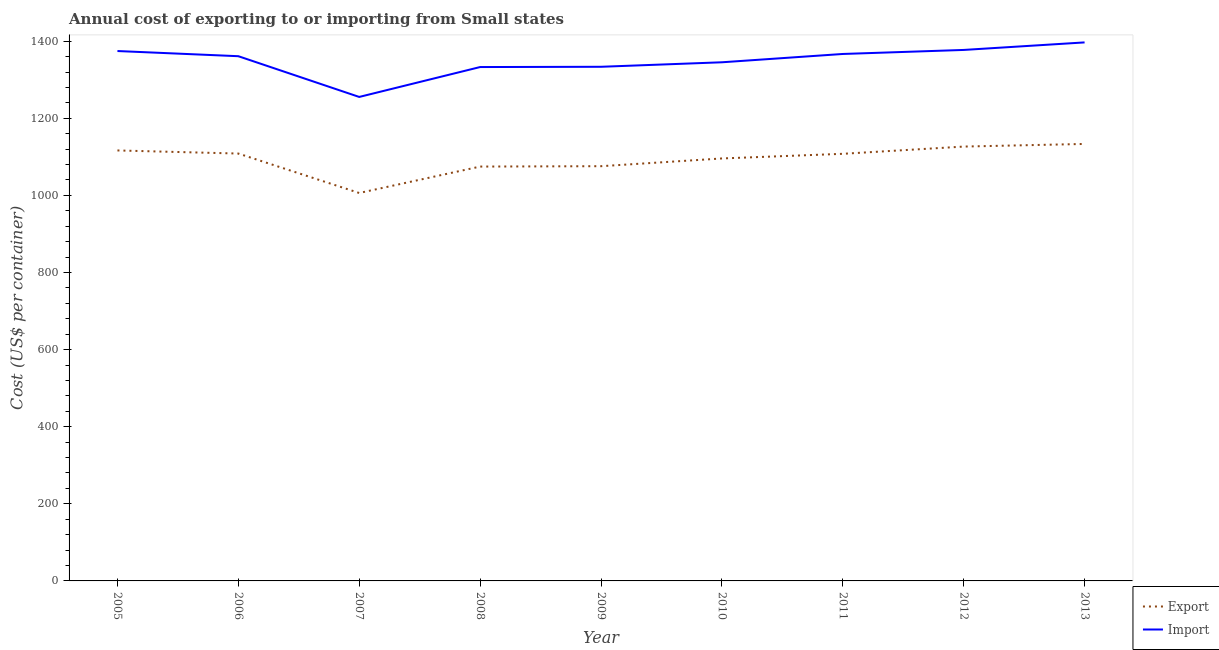How many different coloured lines are there?
Provide a succinct answer. 2. What is the import cost in 2013?
Offer a terse response. 1396.9. Across all years, what is the maximum import cost?
Your answer should be very brief. 1396.9. Across all years, what is the minimum export cost?
Make the answer very short. 1006.28. What is the total export cost in the graph?
Your answer should be compact. 9846.15. What is the difference between the export cost in 2005 and that in 2008?
Keep it short and to the point. 41.83. What is the difference between the import cost in 2010 and the export cost in 2011?
Provide a succinct answer. 237.41. What is the average export cost per year?
Keep it short and to the point. 1094.02. In the year 2011, what is the difference between the import cost and export cost?
Your answer should be compact. 258.98. In how many years, is the import cost greater than 720 US$?
Your response must be concise. 9. What is the ratio of the import cost in 2005 to that in 2008?
Provide a short and direct response. 1.03. Is the export cost in 2010 less than that in 2012?
Ensure brevity in your answer.  Yes. What is the difference between the highest and the second highest export cost?
Keep it short and to the point. 6.83. What is the difference between the highest and the lowest export cost?
Provide a short and direct response. 127.24. In how many years, is the import cost greater than the average import cost taken over all years?
Ensure brevity in your answer.  5. Is the sum of the export cost in 2012 and 2013 greater than the maximum import cost across all years?
Your answer should be very brief. Yes. Is the import cost strictly less than the export cost over the years?
Offer a terse response. No. How many lines are there?
Your answer should be compact. 2. What is the difference between two consecutive major ticks on the Y-axis?
Your answer should be compact. 200. Where does the legend appear in the graph?
Ensure brevity in your answer.  Bottom right. How many legend labels are there?
Your response must be concise. 2. What is the title of the graph?
Ensure brevity in your answer.  Annual cost of exporting to or importing from Small states. What is the label or title of the Y-axis?
Provide a succinct answer. Cost (US$ per container). What is the Cost (US$ per container) of Export in 2005?
Provide a succinct answer. 1116.65. What is the Cost (US$ per container) of Import in 2005?
Offer a very short reply. 1374.51. What is the Cost (US$ per container) of Export in 2006?
Provide a short and direct response. 1108.58. What is the Cost (US$ per container) in Import in 2006?
Offer a very short reply. 1361.11. What is the Cost (US$ per container) in Export in 2007?
Your answer should be compact. 1006.28. What is the Cost (US$ per container) in Import in 2007?
Keep it short and to the point. 1255.44. What is the Cost (US$ per container) in Export in 2008?
Keep it short and to the point. 1074.82. What is the Cost (US$ per container) in Import in 2008?
Ensure brevity in your answer.  1332.97. What is the Cost (US$ per container) in Export in 2009?
Offer a terse response. 1075.79. What is the Cost (US$ per container) in Import in 2009?
Your answer should be very brief. 1333.67. What is the Cost (US$ per container) in Export in 2010?
Keep it short and to the point. 1095.87. What is the Cost (US$ per container) of Import in 2010?
Keep it short and to the point. 1345.33. What is the Cost (US$ per container) in Export in 2011?
Your answer should be compact. 1107.92. What is the Cost (US$ per container) in Import in 2011?
Your response must be concise. 1366.9. What is the Cost (US$ per container) of Export in 2012?
Your answer should be compact. 1126.7. What is the Cost (US$ per container) in Import in 2012?
Offer a very short reply. 1377.35. What is the Cost (US$ per container) in Export in 2013?
Keep it short and to the point. 1133.53. What is the Cost (US$ per container) in Import in 2013?
Give a very brief answer. 1396.9. Across all years, what is the maximum Cost (US$ per container) of Export?
Provide a succinct answer. 1133.53. Across all years, what is the maximum Cost (US$ per container) in Import?
Offer a very short reply. 1396.9. Across all years, what is the minimum Cost (US$ per container) in Export?
Ensure brevity in your answer.  1006.28. Across all years, what is the minimum Cost (US$ per container) in Import?
Provide a succinct answer. 1255.44. What is the total Cost (US$ per container) of Export in the graph?
Provide a succinct answer. 9846.15. What is the total Cost (US$ per container) of Import in the graph?
Your response must be concise. 1.21e+04. What is the difference between the Cost (US$ per container) in Export in 2005 and that in 2006?
Ensure brevity in your answer.  8.07. What is the difference between the Cost (US$ per container) of Import in 2005 and that in 2006?
Keep it short and to the point. 13.41. What is the difference between the Cost (US$ per container) in Export in 2005 and that in 2007?
Give a very brief answer. 110.37. What is the difference between the Cost (US$ per container) in Import in 2005 and that in 2007?
Your answer should be very brief. 119.08. What is the difference between the Cost (US$ per container) of Export in 2005 and that in 2008?
Provide a succinct answer. 41.83. What is the difference between the Cost (US$ per container) of Import in 2005 and that in 2008?
Give a very brief answer. 41.54. What is the difference between the Cost (US$ per container) of Export in 2005 and that in 2009?
Offer a terse response. 40.85. What is the difference between the Cost (US$ per container) in Import in 2005 and that in 2009?
Give a very brief answer. 40.85. What is the difference between the Cost (US$ per container) in Export in 2005 and that in 2010?
Give a very brief answer. 20.78. What is the difference between the Cost (US$ per container) of Import in 2005 and that in 2010?
Offer a very short reply. 29.18. What is the difference between the Cost (US$ per container) in Export in 2005 and that in 2011?
Your answer should be very brief. 8.72. What is the difference between the Cost (US$ per container) of Import in 2005 and that in 2011?
Your answer should be very brief. 7.61. What is the difference between the Cost (US$ per container) in Export in 2005 and that in 2012?
Give a very brief answer. -10.05. What is the difference between the Cost (US$ per container) in Import in 2005 and that in 2012?
Make the answer very short. -2.84. What is the difference between the Cost (US$ per container) of Export in 2005 and that in 2013?
Your response must be concise. -16.88. What is the difference between the Cost (US$ per container) in Import in 2005 and that in 2013?
Make the answer very short. -22.39. What is the difference between the Cost (US$ per container) in Export in 2006 and that in 2007?
Give a very brief answer. 102.3. What is the difference between the Cost (US$ per container) of Import in 2006 and that in 2007?
Your answer should be very brief. 105.67. What is the difference between the Cost (US$ per container) in Export in 2006 and that in 2008?
Make the answer very short. 33.76. What is the difference between the Cost (US$ per container) in Import in 2006 and that in 2008?
Make the answer very short. 28.13. What is the difference between the Cost (US$ per container) in Export in 2006 and that in 2009?
Ensure brevity in your answer.  32.78. What is the difference between the Cost (US$ per container) of Import in 2006 and that in 2009?
Your answer should be compact. 27.44. What is the difference between the Cost (US$ per container) in Export in 2006 and that in 2010?
Your answer should be very brief. 12.71. What is the difference between the Cost (US$ per container) of Import in 2006 and that in 2010?
Make the answer very short. 15.77. What is the difference between the Cost (US$ per container) of Export in 2006 and that in 2011?
Your answer should be very brief. 0.65. What is the difference between the Cost (US$ per container) in Import in 2006 and that in 2011?
Provide a succinct answer. -5.79. What is the difference between the Cost (US$ per container) in Export in 2006 and that in 2012?
Ensure brevity in your answer.  -18.12. What is the difference between the Cost (US$ per container) in Import in 2006 and that in 2012?
Make the answer very short. -16.24. What is the difference between the Cost (US$ per container) in Export in 2006 and that in 2013?
Ensure brevity in your answer.  -24.95. What is the difference between the Cost (US$ per container) in Import in 2006 and that in 2013?
Offer a very short reply. -35.79. What is the difference between the Cost (US$ per container) of Export in 2007 and that in 2008?
Your answer should be compact. -68.54. What is the difference between the Cost (US$ per container) in Import in 2007 and that in 2008?
Keep it short and to the point. -77.54. What is the difference between the Cost (US$ per container) of Export in 2007 and that in 2009?
Provide a succinct answer. -69.51. What is the difference between the Cost (US$ per container) of Import in 2007 and that in 2009?
Offer a terse response. -78.23. What is the difference between the Cost (US$ per container) in Export in 2007 and that in 2010?
Keep it short and to the point. -89.59. What is the difference between the Cost (US$ per container) of Import in 2007 and that in 2010?
Offer a terse response. -89.9. What is the difference between the Cost (US$ per container) in Export in 2007 and that in 2011?
Provide a succinct answer. -101.64. What is the difference between the Cost (US$ per container) in Import in 2007 and that in 2011?
Make the answer very short. -111.46. What is the difference between the Cost (US$ per container) of Export in 2007 and that in 2012?
Give a very brief answer. -120.42. What is the difference between the Cost (US$ per container) of Import in 2007 and that in 2012?
Your answer should be very brief. -121.91. What is the difference between the Cost (US$ per container) in Export in 2007 and that in 2013?
Provide a short and direct response. -127.24. What is the difference between the Cost (US$ per container) of Import in 2007 and that in 2013?
Provide a succinct answer. -141.46. What is the difference between the Cost (US$ per container) of Export in 2008 and that in 2009?
Provide a succinct answer. -0.97. What is the difference between the Cost (US$ per container) in Import in 2008 and that in 2009?
Make the answer very short. -0.69. What is the difference between the Cost (US$ per container) of Export in 2008 and that in 2010?
Your answer should be compact. -21.05. What is the difference between the Cost (US$ per container) in Import in 2008 and that in 2010?
Ensure brevity in your answer.  -12.36. What is the difference between the Cost (US$ per container) of Export in 2008 and that in 2011?
Make the answer very short. -33.1. What is the difference between the Cost (US$ per container) in Import in 2008 and that in 2011?
Ensure brevity in your answer.  -33.93. What is the difference between the Cost (US$ per container) of Export in 2008 and that in 2012?
Offer a terse response. -51.88. What is the difference between the Cost (US$ per container) in Import in 2008 and that in 2012?
Provide a short and direct response. -44.38. What is the difference between the Cost (US$ per container) of Export in 2008 and that in 2013?
Your answer should be compact. -58.7. What is the difference between the Cost (US$ per container) of Import in 2008 and that in 2013?
Your response must be concise. -63.93. What is the difference between the Cost (US$ per container) in Export in 2009 and that in 2010?
Give a very brief answer. -20.08. What is the difference between the Cost (US$ per container) in Import in 2009 and that in 2010?
Provide a short and direct response. -11.67. What is the difference between the Cost (US$ per container) in Export in 2009 and that in 2011?
Give a very brief answer. -32.13. What is the difference between the Cost (US$ per container) in Import in 2009 and that in 2011?
Make the answer very short. -33.23. What is the difference between the Cost (US$ per container) in Export in 2009 and that in 2012?
Your response must be concise. -50.91. What is the difference between the Cost (US$ per container) of Import in 2009 and that in 2012?
Provide a short and direct response. -43.68. What is the difference between the Cost (US$ per container) of Export in 2009 and that in 2013?
Your response must be concise. -57.73. What is the difference between the Cost (US$ per container) of Import in 2009 and that in 2013?
Provide a succinct answer. -63.23. What is the difference between the Cost (US$ per container) of Export in 2010 and that in 2011?
Your answer should be very brief. -12.05. What is the difference between the Cost (US$ per container) in Import in 2010 and that in 2011?
Provide a succinct answer. -21.57. What is the difference between the Cost (US$ per container) of Export in 2010 and that in 2012?
Offer a terse response. -30.83. What is the difference between the Cost (US$ per container) of Import in 2010 and that in 2012?
Ensure brevity in your answer.  -32.02. What is the difference between the Cost (US$ per container) in Export in 2010 and that in 2013?
Provide a succinct answer. -37.65. What is the difference between the Cost (US$ per container) in Import in 2010 and that in 2013?
Offer a very short reply. -51.57. What is the difference between the Cost (US$ per container) in Export in 2011 and that in 2012?
Keep it short and to the point. -18.77. What is the difference between the Cost (US$ per container) of Import in 2011 and that in 2012?
Your answer should be very brief. -10.45. What is the difference between the Cost (US$ per container) in Export in 2011 and that in 2013?
Make the answer very short. -25.6. What is the difference between the Cost (US$ per container) in Import in 2011 and that in 2013?
Ensure brevity in your answer.  -30. What is the difference between the Cost (US$ per container) in Export in 2012 and that in 2013?
Ensure brevity in your answer.  -6.83. What is the difference between the Cost (US$ per container) in Import in 2012 and that in 2013?
Make the answer very short. -19.55. What is the difference between the Cost (US$ per container) of Export in 2005 and the Cost (US$ per container) of Import in 2006?
Offer a terse response. -244.46. What is the difference between the Cost (US$ per container) in Export in 2005 and the Cost (US$ per container) in Import in 2007?
Provide a succinct answer. -138.79. What is the difference between the Cost (US$ per container) of Export in 2005 and the Cost (US$ per container) of Import in 2008?
Make the answer very short. -216.33. What is the difference between the Cost (US$ per container) of Export in 2005 and the Cost (US$ per container) of Import in 2009?
Offer a terse response. -217.02. What is the difference between the Cost (US$ per container) of Export in 2005 and the Cost (US$ per container) of Import in 2010?
Make the answer very short. -228.68. What is the difference between the Cost (US$ per container) of Export in 2005 and the Cost (US$ per container) of Import in 2011?
Your answer should be very brief. -250.25. What is the difference between the Cost (US$ per container) of Export in 2005 and the Cost (US$ per container) of Import in 2012?
Your answer should be very brief. -260.7. What is the difference between the Cost (US$ per container) in Export in 2005 and the Cost (US$ per container) in Import in 2013?
Your response must be concise. -280.25. What is the difference between the Cost (US$ per container) of Export in 2006 and the Cost (US$ per container) of Import in 2007?
Provide a succinct answer. -146.86. What is the difference between the Cost (US$ per container) in Export in 2006 and the Cost (US$ per container) in Import in 2008?
Your response must be concise. -224.4. What is the difference between the Cost (US$ per container) in Export in 2006 and the Cost (US$ per container) in Import in 2009?
Give a very brief answer. -225.09. What is the difference between the Cost (US$ per container) in Export in 2006 and the Cost (US$ per container) in Import in 2010?
Ensure brevity in your answer.  -236.75. What is the difference between the Cost (US$ per container) in Export in 2006 and the Cost (US$ per container) in Import in 2011?
Your answer should be compact. -258.32. What is the difference between the Cost (US$ per container) in Export in 2006 and the Cost (US$ per container) in Import in 2012?
Give a very brief answer. -268.77. What is the difference between the Cost (US$ per container) in Export in 2006 and the Cost (US$ per container) in Import in 2013?
Offer a very short reply. -288.32. What is the difference between the Cost (US$ per container) in Export in 2007 and the Cost (US$ per container) in Import in 2008?
Ensure brevity in your answer.  -326.69. What is the difference between the Cost (US$ per container) of Export in 2007 and the Cost (US$ per container) of Import in 2009?
Your answer should be compact. -327.38. What is the difference between the Cost (US$ per container) in Export in 2007 and the Cost (US$ per container) in Import in 2010?
Your response must be concise. -339.05. What is the difference between the Cost (US$ per container) of Export in 2007 and the Cost (US$ per container) of Import in 2011?
Keep it short and to the point. -360.62. What is the difference between the Cost (US$ per container) in Export in 2007 and the Cost (US$ per container) in Import in 2012?
Provide a short and direct response. -371.07. What is the difference between the Cost (US$ per container) of Export in 2007 and the Cost (US$ per container) of Import in 2013?
Make the answer very short. -390.62. What is the difference between the Cost (US$ per container) in Export in 2008 and the Cost (US$ per container) in Import in 2009?
Provide a succinct answer. -258.85. What is the difference between the Cost (US$ per container) of Export in 2008 and the Cost (US$ per container) of Import in 2010?
Make the answer very short. -270.51. What is the difference between the Cost (US$ per container) of Export in 2008 and the Cost (US$ per container) of Import in 2011?
Your response must be concise. -292.08. What is the difference between the Cost (US$ per container) in Export in 2008 and the Cost (US$ per container) in Import in 2012?
Offer a very short reply. -302.53. What is the difference between the Cost (US$ per container) in Export in 2008 and the Cost (US$ per container) in Import in 2013?
Keep it short and to the point. -322.08. What is the difference between the Cost (US$ per container) in Export in 2009 and the Cost (US$ per container) in Import in 2010?
Give a very brief answer. -269.54. What is the difference between the Cost (US$ per container) of Export in 2009 and the Cost (US$ per container) of Import in 2011?
Offer a very short reply. -291.11. What is the difference between the Cost (US$ per container) of Export in 2009 and the Cost (US$ per container) of Import in 2012?
Ensure brevity in your answer.  -301.56. What is the difference between the Cost (US$ per container) of Export in 2009 and the Cost (US$ per container) of Import in 2013?
Provide a short and direct response. -321.11. What is the difference between the Cost (US$ per container) in Export in 2010 and the Cost (US$ per container) in Import in 2011?
Make the answer very short. -271.03. What is the difference between the Cost (US$ per container) in Export in 2010 and the Cost (US$ per container) in Import in 2012?
Ensure brevity in your answer.  -281.48. What is the difference between the Cost (US$ per container) in Export in 2010 and the Cost (US$ per container) in Import in 2013?
Offer a very short reply. -301.03. What is the difference between the Cost (US$ per container) of Export in 2011 and the Cost (US$ per container) of Import in 2012?
Provide a short and direct response. -269.43. What is the difference between the Cost (US$ per container) in Export in 2011 and the Cost (US$ per container) in Import in 2013?
Make the answer very short. -288.98. What is the difference between the Cost (US$ per container) in Export in 2012 and the Cost (US$ per container) in Import in 2013?
Make the answer very short. -270.2. What is the average Cost (US$ per container) in Export per year?
Provide a short and direct response. 1094.02. What is the average Cost (US$ per container) of Import per year?
Your response must be concise. 1349.35. In the year 2005, what is the difference between the Cost (US$ per container) in Export and Cost (US$ per container) in Import?
Your answer should be very brief. -257.86. In the year 2006, what is the difference between the Cost (US$ per container) in Export and Cost (US$ per container) in Import?
Your response must be concise. -252.53. In the year 2007, what is the difference between the Cost (US$ per container) in Export and Cost (US$ per container) in Import?
Offer a terse response. -249.15. In the year 2008, what is the difference between the Cost (US$ per container) in Export and Cost (US$ per container) in Import?
Your answer should be very brief. -258.15. In the year 2009, what is the difference between the Cost (US$ per container) of Export and Cost (US$ per container) of Import?
Keep it short and to the point. -257.87. In the year 2010, what is the difference between the Cost (US$ per container) of Export and Cost (US$ per container) of Import?
Ensure brevity in your answer.  -249.46. In the year 2011, what is the difference between the Cost (US$ per container) in Export and Cost (US$ per container) in Import?
Provide a succinct answer. -258.98. In the year 2012, what is the difference between the Cost (US$ per container) in Export and Cost (US$ per container) in Import?
Make the answer very short. -250.65. In the year 2013, what is the difference between the Cost (US$ per container) in Export and Cost (US$ per container) in Import?
Your answer should be very brief. -263.38. What is the ratio of the Cost (US$ per container) in Export in 2005 to that in 2006?
Provide a succinct answer. 1.01. What is the ratio of the Cost (US$ per container) of Import in 2005 to that in 2006?
Offer a very short reply. 1.01. What is the ratio of the Cost (US$ per container) in Export in 2005 to that in 2007?
Your answer should be compact. 1.11. What is the ratio of the Cost (US$ per container) in Import in 2005 to that in 2007?
Your answer should be very brief. 1.09. What is the ratio of the Cost (US$ per container) of Export in 2005 to that in 2008?
Offer a terse response. 1.04. What is the ratio of the Cost (US$ per container) in Import in 2005 to that in 2008?
Ensure brevity in your answer.  1.03. What is the ratio of the Cost (US$ per container) in Export in 2005 to that in 2009?
Your answer should be very brief. 1.04. What is the ratio of the Cost (US$ per container) in Import in 2005 to that in 2009?
Offer a very short reply. 1.03. What is the ratio of the Cost (US$ per container) in Import in 2005 to that in 2010?
Offer a very short reply. 1.02. What is the ratio of the Cost (US$ per container) of Export in 2005 to that in 2011?
Offer a terse response. 1.01. What is the ratio of the Cost (US$ per container) of Import in 2005 to that in 2011?
Your answer should be very brief. 1.01. What is the ratio of the Cost (US$ per container) of Export in 2005 to that in 2013?
Provide a succinct answer. 0.99. What is the ratio of the Cost (US$ per container) in Import in 2005 to that in 2013?
Your response must be concise. 0.98. What is the ratio of the Cost (US$ per container) in Export in 2006 to that in 2007?
Provide a succinct answer. 1.1. What is the ratio of the Cost (US$ per container) in Import in 2006 to that in 2007?
Provide a short and direct response. 1.08. What is the ratio of the Cost (US$ per container) of Export in 2006 to that in 2008?
Offer a very short reply. 1.03. What is the ratio of the Cost (US$ per container) of Import in 2006 to that in 2008?
Make the answer very short. 1.02. What is the ratio of the Cost (US$ per container) of Export in 2006 to that in 2009?
Provide a short and direct response. 1.03. What is the ratio of the Cost (US$ per container) of Import in 2006 to that in 2009?
Your answer should be compact. 1.02. What is the ratio of the Cost (US$ per container) in Export in 2006 to that in 2010?
Your response must be concise. 1.01. What is the ratio of the Cost (US$ per container) of Import in 2006 to that in 2010?
Keep it short and to the point. 1.01. What is the ratio of the Cost (US$ per container) in Export in 2006 to that in 2011?
Your answer should be compact. 1. What is the ratio of the Cost (US$ per container) in Import in 2006 to that in 2011?
Your answer should be compact. 1. What is the ratio of the Cost (US$ per container) of Export in 2006 to that in 2012?
Keep it short and to the point. 0.98. What is the ratio of the Cost (US$ per container) of Import in 2006 to that in 2012?
Offer a very short reply. 0.99. What is the ratio of the Cost (US$ per container) in Export in 2006 to that in 2013?
Your response must be concise. 0.98. What is the ratio of the Cost (US$ per container) of Import in 2006 to that in 2013?
Give a very brief answer. 0.97. What is the ratio of the Cost (US$ per container) of Export in 2007 to that in 2008?
Your answer should be compact. 0.94. What is the ratio of the Cost (US$ per container) in Import in 2007 to that in 2008?
Your answer should be very brief. 0.94. What is the ratio of the Cost (US$ per container) in Export in 2007 to that in 2009?
Your response must be concise. 0.94. What is the ratio of the Cost (US$ per container) of Import in 2007 to that in 2009?
Ensure brevity in your answer.  0.94. What is the ratio of the Cost (US$ per container) of Export in 2007 to that in 2010?
Make the answer very short. 0.92. What is the ratio of the Cost (US$ per container) of Import in 2007 to that in 2010?
Provide a short and direct response. 0.93. What is the ratio of the Cost (US$ per container) of Export in 2007 to that in 2011?
Offer a very short reply. 0.91. What is the ratio of the Cost (US$ per container) of Import in 2007 to that in 2011?
Provide a short and direct response. 0.92. What is the ratio of the Cost (US$ per container) in Export in 2007 to that in 2012?
Your answer should be compact. 0.89. What is the ratio of the Cost (US$ per container) of Import in 2007 to that in 2012?
Your response must be concise. 0.91. What is the ratio of the Cost (US$ per container) in Export in 2007 to that in 2013?
Give a very brief answer. 0.89. What is the ratio of the Cost (US$ per container) of Import in 2007 to that in 2013?
Offer a very short reply. 0.9. What is the ratio of the Cost (US$ per container) of Export in 2008 to that in 2010?
Your answer should be compact. 0.98. What is the ratio of the Cost (US$ per container) in Export in 2008 to that in 2011?
Provide a succinct answer. 0.97. What is the ratio of the Cost (US$ per container) of Import in 2008 to that in 2011?
Keep it short and to the point. 0.98. What is the ratio of the Cost (US$ per container) in Export in 2008 to that in 2012?
Make the answer very short. 0.95. What is the ratio of the Cost (US$ per container) of Import in 2008 to that in 2012?
Make the answer very short. 0.97. What is the ratio of the Cost (US$ per container) in Export in 2008 to that in 2013?
Your response must be concise. 0.95. What is the ratio of the Cost (US$ per container) of Import in 2008 to that in 2013?
Give a very brief answer. 0.95. What is the ratio of the Cost (US$ per container) of Export in 2009 to that in 2010?
Your response must be concise. 0.98. What is the ratio of the Cost (US$ per container) in Import in 2009 to that in 2011?
Your answer should be compact. 0.98. What is the ratio of the Cost (US$ per container) in Export in 2009 to that in 2012?
Keep it short and to the point. 0.95. What is the ratio of the Cost (US$ per container) of Import in 2009 to that in 2012?
Ensure brevity in your answer.  0.97. What is the ratio of the Cost (US$ per container) in Export in 2009 to that in 2013?
Your response must be concise. 0.95. What is the ratio of the Cost (US$ per container) of Import in 2009 to that in 2013?
Your response must be concise. 0.95. What is the ratio of the Cost (US$ per container) of Import in 2010 to that in 2011?
Your answer should be very brief. 0.98. What is the ratio of the Cost (US$ per container) of Export in 2010 to that in 2012?
Give a very brief answer. 0.97. What is the ratio of the Cost (US$ per container) in Import in 2010 to that in 2012?
Provide a short and direct response. 0.98. What is the ratio of the Cost (US$ per container) in Export in 2010 to that in 2013?
Ensure brevity in your answer.  0.97. What is the ratio of the Cost (US$ per container) in Import in 2010 to that in 2013?
Provide a succinct answer. 0.96. What is the ratio of the Cost (US$ per container) in Export in 2011 to that in 2012?
Make the answer very short. 0.98. What is the ratio of the Cost (US$ per container) in Export in 2011 to that in 2013?
Offer a terse response. 0.98. What is the ratio of the Cost (US$ per container) in Import in 2011 to that in 2013?
Provide a short and direct response. 0.98. What is the difference between the highest and the second highest Cost (US$ per container) in Export?
Provide a short and direct response. 6.83. What is the difference between the highest and the second highest Cost (US$ per container) in Import?
Give a very brief answer. 19.55. What is the difference between the highest and the lowest Cost (US$ per container) in Export?
Give a very brief answer. 127.24. What is the difference between the highest and the lowest Cost (US$ per container) of Import?
Keep it short and to the point. 141.46. 